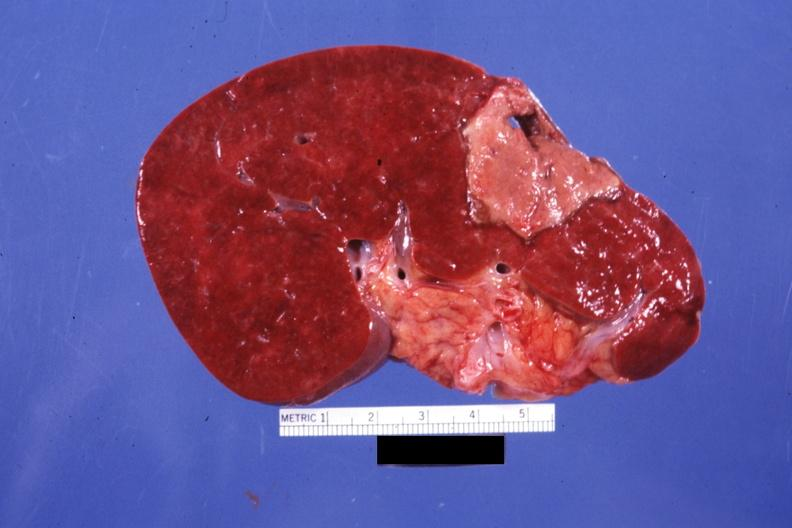does pituitary show large and typically shaped old infarct but far from fibrotic?
Answer the question using a single word or phrase. No 